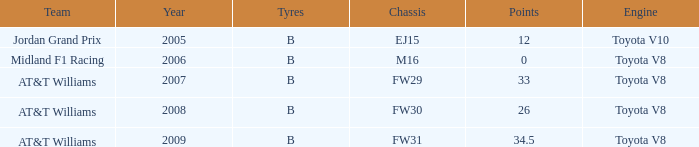What is the low point total after 2006 with an m16 chassis? None. 